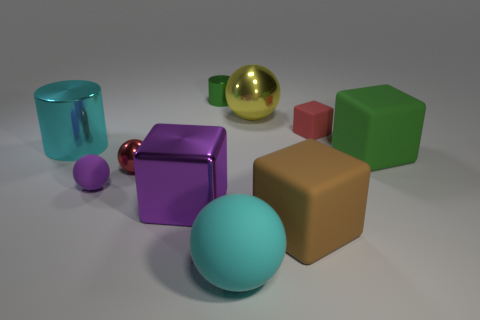Subtract all brown blocks. How many blocks are left? 3 Subtract all big yellow metal balls. How many balls are left? 3 Subtract all cyan blocks. Subtract all cyan balls. How many blocks are left? 4 Add 5 small red shiny spheres. How many small red shiny spheres exist? 6 Subtract 1 yellow spheres. How many objects are left? 9 Subtract all cylinders. How many objects are left? 8 Subtract all big matte cubes. Subtract all cyan spheres. How many objects are left? 7 Add 6 small shiny balls. How many small shiny balls are left? 7 